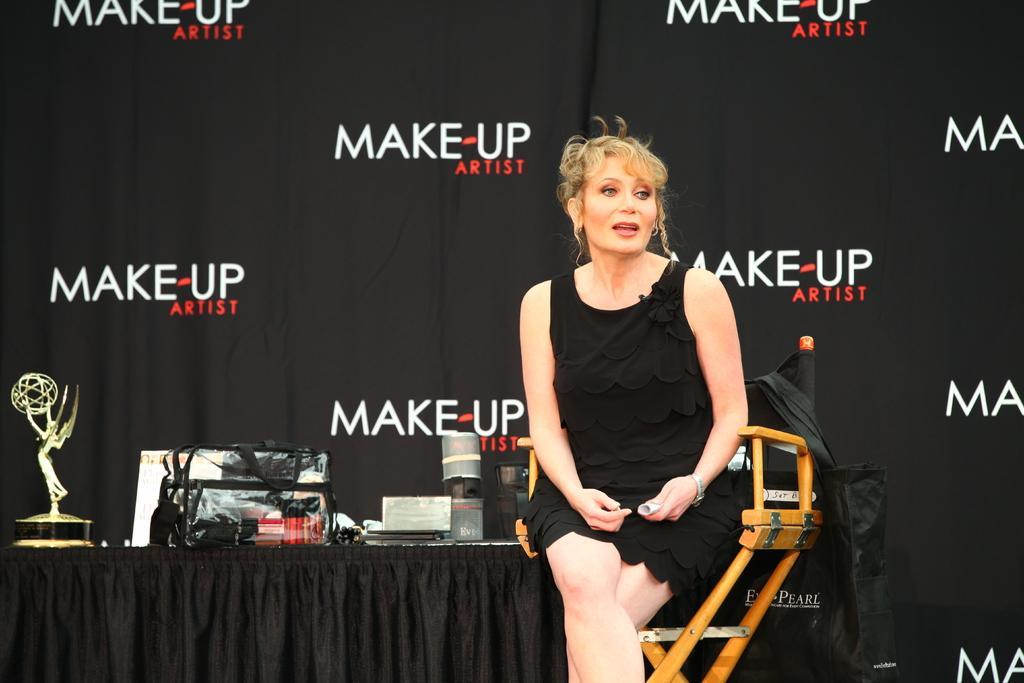Please provide a concise description of this image. In this image we can see a woman is sitting on the chair. She is wearing a black color dress and holding an object in her hand. Behind her, we can see a table. On the table, we can see a trophy, bag and so many objects. In the background, we can see the banner. We can see a bag on the right side of the image. 